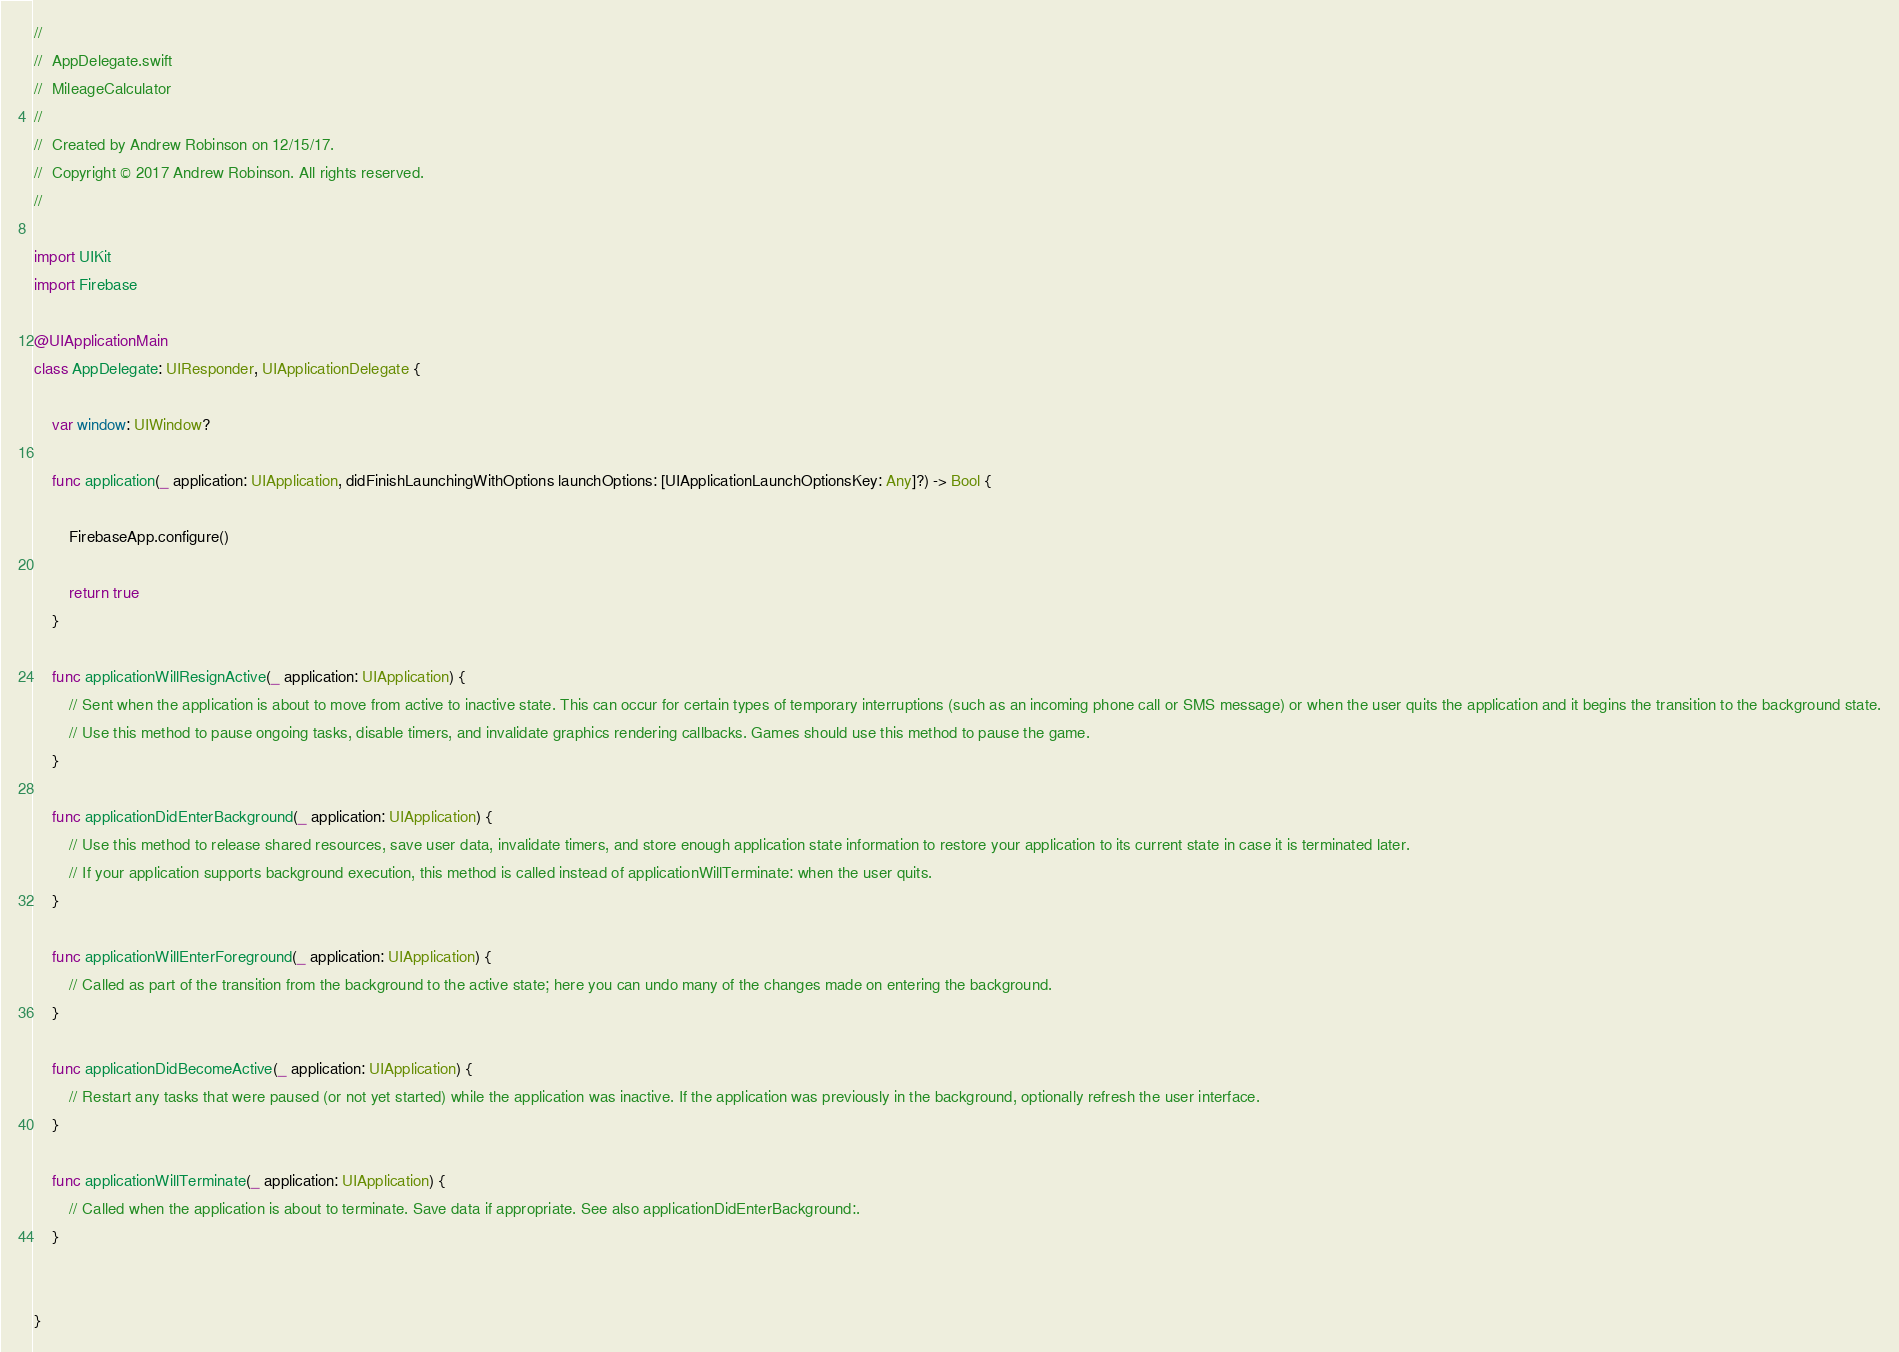<code> <loc_0><loc_0><loc_500><loc_500><_Swift_>//
//  AppDelegate.swift
//  MileageCalculator
//
//  Created by Andrew Robinson on 12/15/17.
//  Copyright © 2017 Andrew Robinson. All rights reserved.
//

import UIKit
import Firebase

@UIApplicationMain
class AppDelegate: UIResponder, UIApplicationDelegate {

    var window: UIWindow?

    func application(_ application: UIApplication, didFinishLaunchingWithOptions launchOptions: [UIApplicationLaunchOptionsKey: Any]?) -> Bool {

        FirebaseApp.configure()

        return true
    }

    func applicationWillResignActive(_ application: UIApplication) {
        // Sent when the application is about to move from active to inactive state. This can occur for certain types of temporary interruptions (such as an incoming phone call or SMS message) or when the user quits the application and it begins the transition to the background state.
        // Use this method to pause ongoing tasks, disable timers, and invalidate graphics rendering callbacks. Games should use this method to pause the game.
    }

    func applicationDidEnterBackground(_ application: UIApplication) {
        // Use this method to release shared resources, save user data, invalidate timers, and store enough application state information to restore your application to its current state in case it is terminated later.
        // If your application supports background execution, this method is called instead of applicationWillTerminate: when the user quits.
    }

    func applicationWillEnterForeground(_ application: UIApplication) {
        // Called as part of the transition from the background to the active state; here you can undo many of the changes made on entering the background.
    }

    func applicationDidBecomeActive(_ application: UIApplication) {
        // Restart any tasks that were paused (or not yet started) while the application was inactive. If the application was previously in the background, optionally refresh the user interface.
    }

    func applicationWillTerminate(_ application: UIApplication) {
        // Called when the application is about to terminate. Save data if appropriate. See also applicationDidEnterBackground:.
    }


}

</code> 